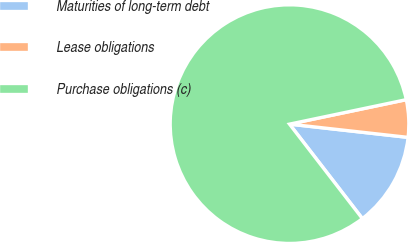Convert chart to OTSL. <chart><loc_0><loc_0><loc_500><loc_500><pie_chart><fcel>Maturities of long-term debt<fcel>Lease obligations<fcel>Purchase obligations (c)<nl><fcel>12.77%<fcel>5.06%<fcel>82.16%<nl></chart> 